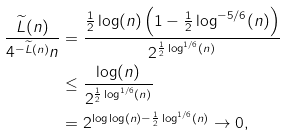Convert formula to latex. <formula><loc_0><loc_0><loc_500><loc_500>\frac { \widetilde { L } ( n ) } { 4 ^ { - \widetilde { L } ( n ) } n } & = \frac { \frac { 1 } { 2 } \log ( n ) \left ( 1 - \frac { 1 } { 2 } \log ^ { - 5 / 6 } ( n ) \right ) } { 2 ^ { \frac { 1 } { 2 } \log ^ { 1 / 6 } ( n ) } } \\ & \leq \frac { \log ( n ) } { 2 ^ { \frac { 1 } { 2 } \log ^ { 1 / 6 } ( n ) } } \\ & = 2 ^ { \log \log ( n ) - \frac { 1 } { 2 } \log ^ { 1 / 6 } ( n ) } \to 0 ,</formula> 